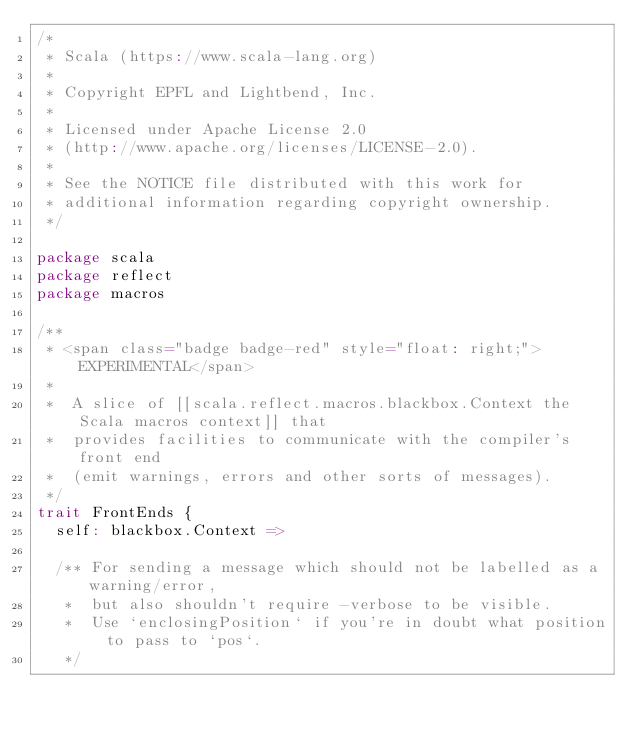<code> <loc_0><loc_0><loc_500><loc_500><_Scala_>/*
 * Scala (https://www.scala-lang.org)
 *
 * Copyright EPFL and Lightbend, Inc.
 *
 * Licensed under Apache License 2.0
 * (http://www.apache.org/licenses/LICENSE-2.0).
 *
 * See the NOTICE file distributed with this work for
 * additional information regarding copyright ownership.
 */

package scala
package reflect
package macros

/**
 * <span class="badge badge-red" style="float: right;">EXPERIMENTAL</span>
 *
 *  A slice of [[scala.reflect.macros.blackbox.Context the Scala macros context]] that
 *  provides facilities to communicate with the compiler's front end
 *  (emit warnings, errors and other sorts of messages).
 */
trait FrontEnds {
  self: blackbox.Context =>

  /** For sending a message which should not be labelled as a warning/error,
   *  but also shouldn't require -verbose to be visible.
   *  Use `enclosingPosition` if you're in doubt what position to pass to `pos`.
   */</code> 